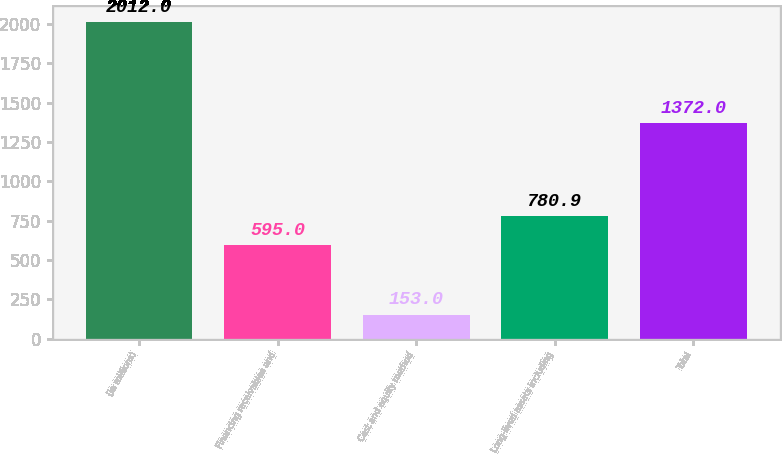Convert chart. <chart><loc_0><loc_0><loc_500><loc_500><bar_chart><fcel>(In millions)<fcel>Financing receivables and<fcel>Cost and equity method<fcel>Long-lived assets including<fcel>Total<nl><fcel>2012<fcel>595<fcel>153<fcel>780.9<fcel>1372<nl></chart> 